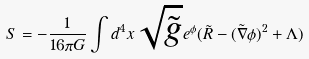<formula> <loc_0><loc_0><loc_500><loc_500>S = - \frac { 1 } { 1 6 \pi G } \int d ^ { 4 } x \sqrt { \tilde { g } } e ^ { \phi } ( \tilde { R } - ( \tilde { \nabla } \phi ) ^ { 2 } + \Lambda )</formula> 